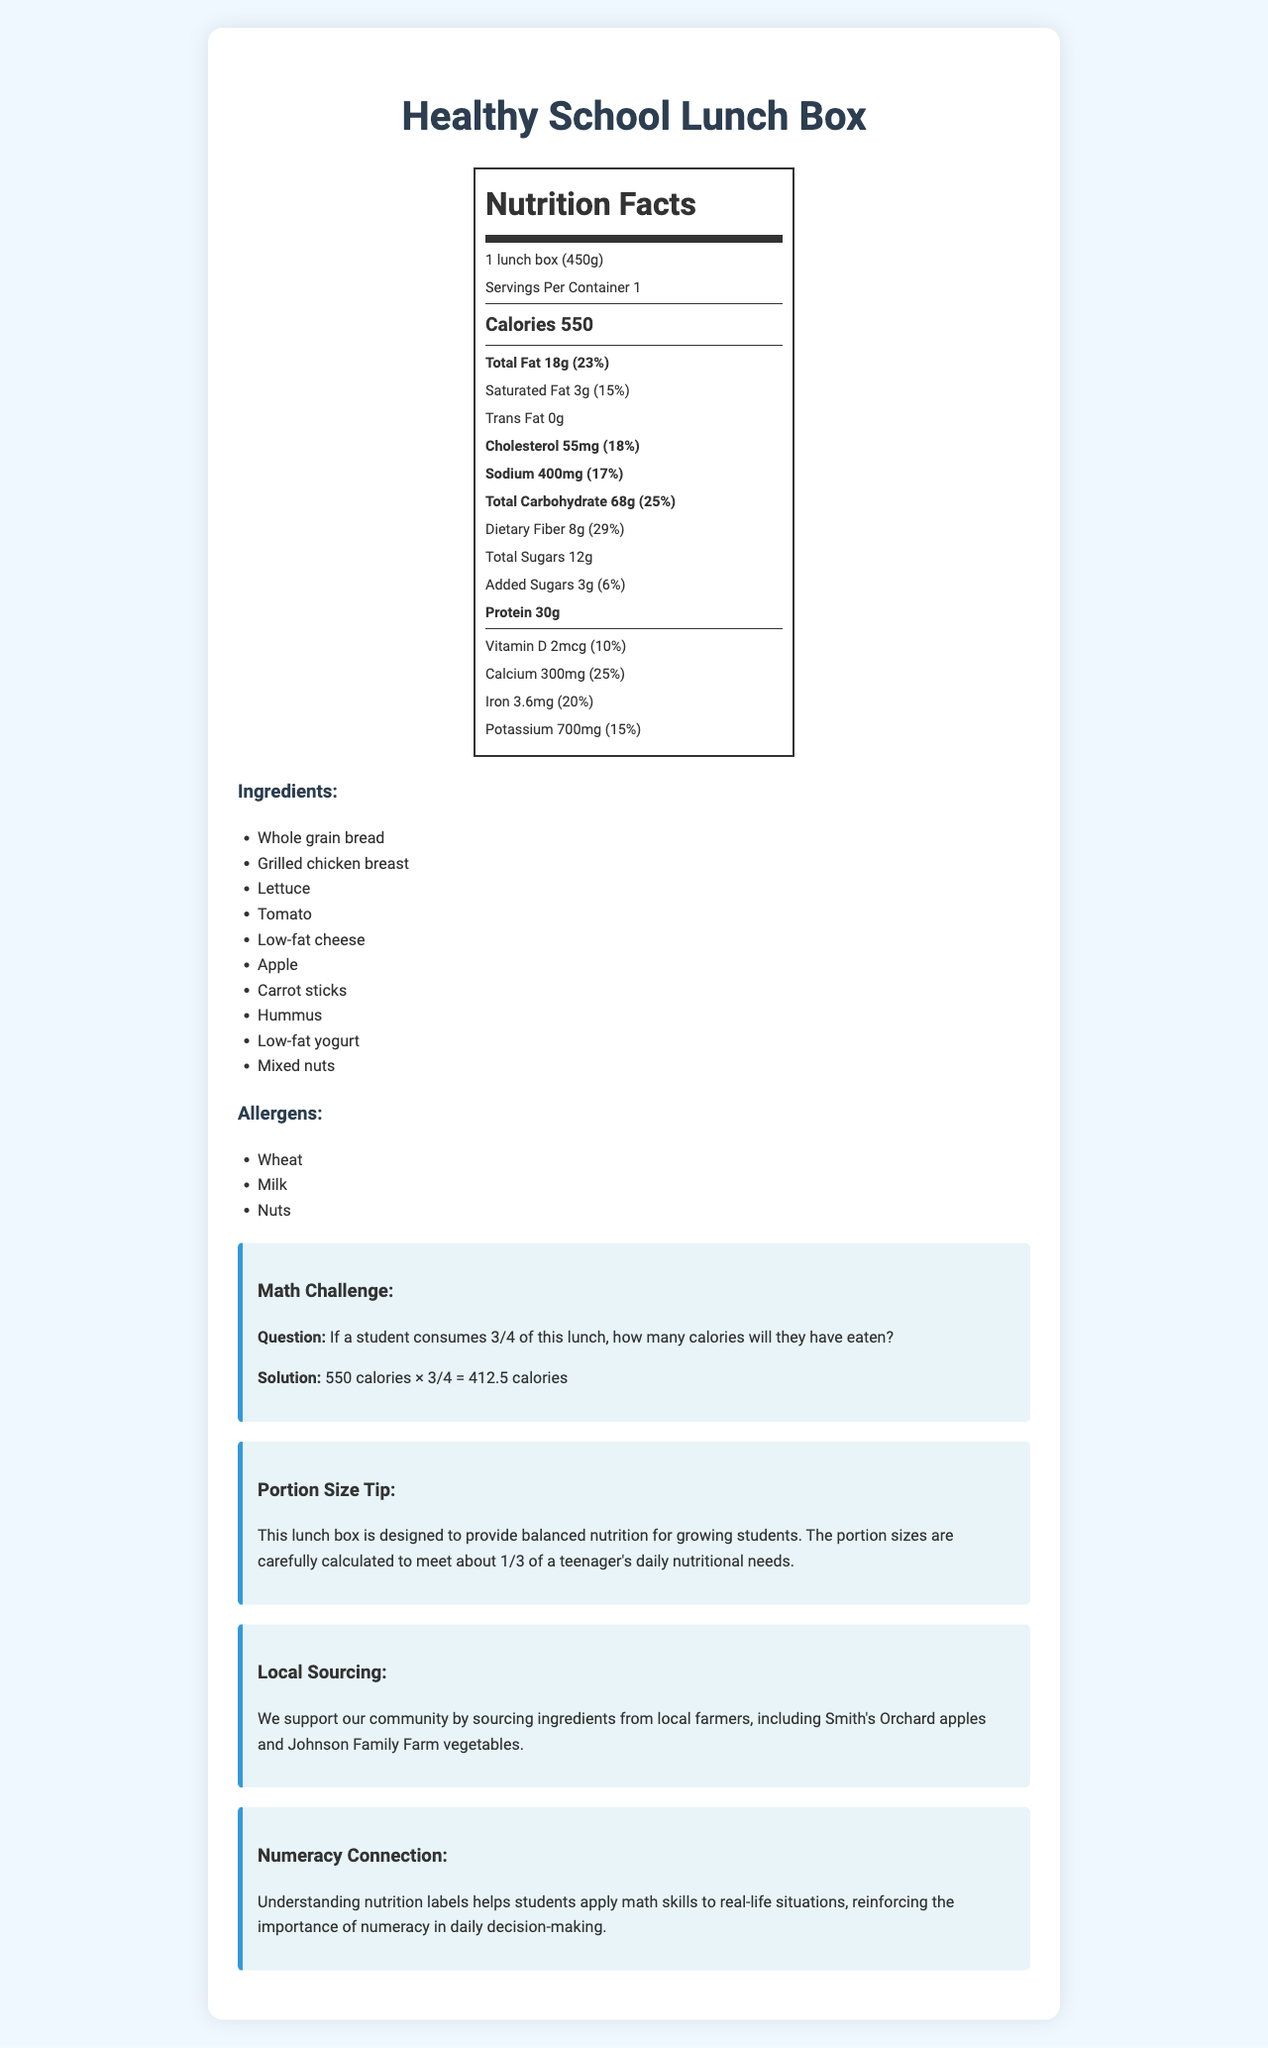what is the serving size of the Healthy School Lunch Box? The serving size is stated clearly under the product name in the nutrition label.
Answer: 1 lunch box (450g) how many calories are in one serving of the Healthy School Lunch Box? The calorie amount is listed under "Calories" in bold in the nutrition label.
Answer: 550 calories how much dietary fiber does one serving contain? The amount of dietary fiber is listed under "Dietary Fiber" within the "Total Carbohydrate" section.
Answer: 8g name one of the allergens present in the Healthy School Lunch Box. The allergen "Wheat" is listed under the "Allergens" section.
Answer: Wheat is there any trans fat in the Healthy School Lunch Box? The trans fat amount is stated as "0g" in the nutrition label.
Answer: No if a student consumes 1/2 of this lunch box, how many calories will they have eaten? The calculation involves halving the total calories: \(550 \, \text{calories} \times \frac{1}{2} = 275 \, \text{calories}\).
Answer: 275 calories which ingredient is not included in the Healthy School Lunch Box? A. Grilled chicken breast B. Lettuce C. Rice Rice is not listed among the ingredients, while grilled chicken breast and lettuce are.
Answer: C what is the daily value percentage of calcium provided in one serving? A. 10% B. 20% C. 25% D. 30% The daily value for calcium is listed as 25%.
Answer: C is the sodium content in this lunch box 17% of the daily value? The sodium content is listed as "400mg" which is 17% of the daily value.
Answer: Yes describe the main idea of the document. The document provides detailed nutritional information to help consumers understand the healthfulness of the lunch box, and engages students in applying math to real-life scenarios.
Answer: The document is a nutrition facts label for a Healthy School Lunch Box. It lists the product's serving size, calorie count, and nutritional information (e.g., fat, cholesterol, sodium, carbohydrates, sugars, protein, vitamins, and minerals). The label also includes a math challenge to help students apply numeracy skills, details on portion sizes, local sourcing of ingredients, and common allergens. how many servings are in each container? The number of servings per container is indicated as "1" in the nutrition label.
Answer: 1 how much potassium is in one serving? The potassium content is listed under the vitamins and minerals section.
Answer: 700mg what is the amount of added sugars? The added sugars are specified in the nutrition facts label under "Added Sugars".
Answer: 3g calculate the daily value percentage represented by the saturated fat content. The daily value percentage for saturated fat is given as 15%.
Answer: 15% which of the following local farms provides ingredients for the lunch box? A. Johnson Family Farm B. Thompson Ranch C. Hilltop Dairy Johnson Family Farm is mentioned as a source of vegetables for the lunch box.
Answer: A what is the math challenge included in the document? The math challenge question is explicitly described under the math challenge section.
Answer: If a student consumes 3/4 of this lunch, how many calories will they have eaten? is the product description helpful for understanding portion sizes? The portion size tip section provides additional information on how the lunch box portion sizes are calculated to meet nutritional needs.
Answer: Yes how many grams of protein are present in each serving? The amount of protein is listed under "Protein" in the nutrition label.
Answer: 30g can you determine the price of the Healthy School Lunch Box from this document? Price information is not included in the provided nutrition facts label.
Answer: Cannot be determined 